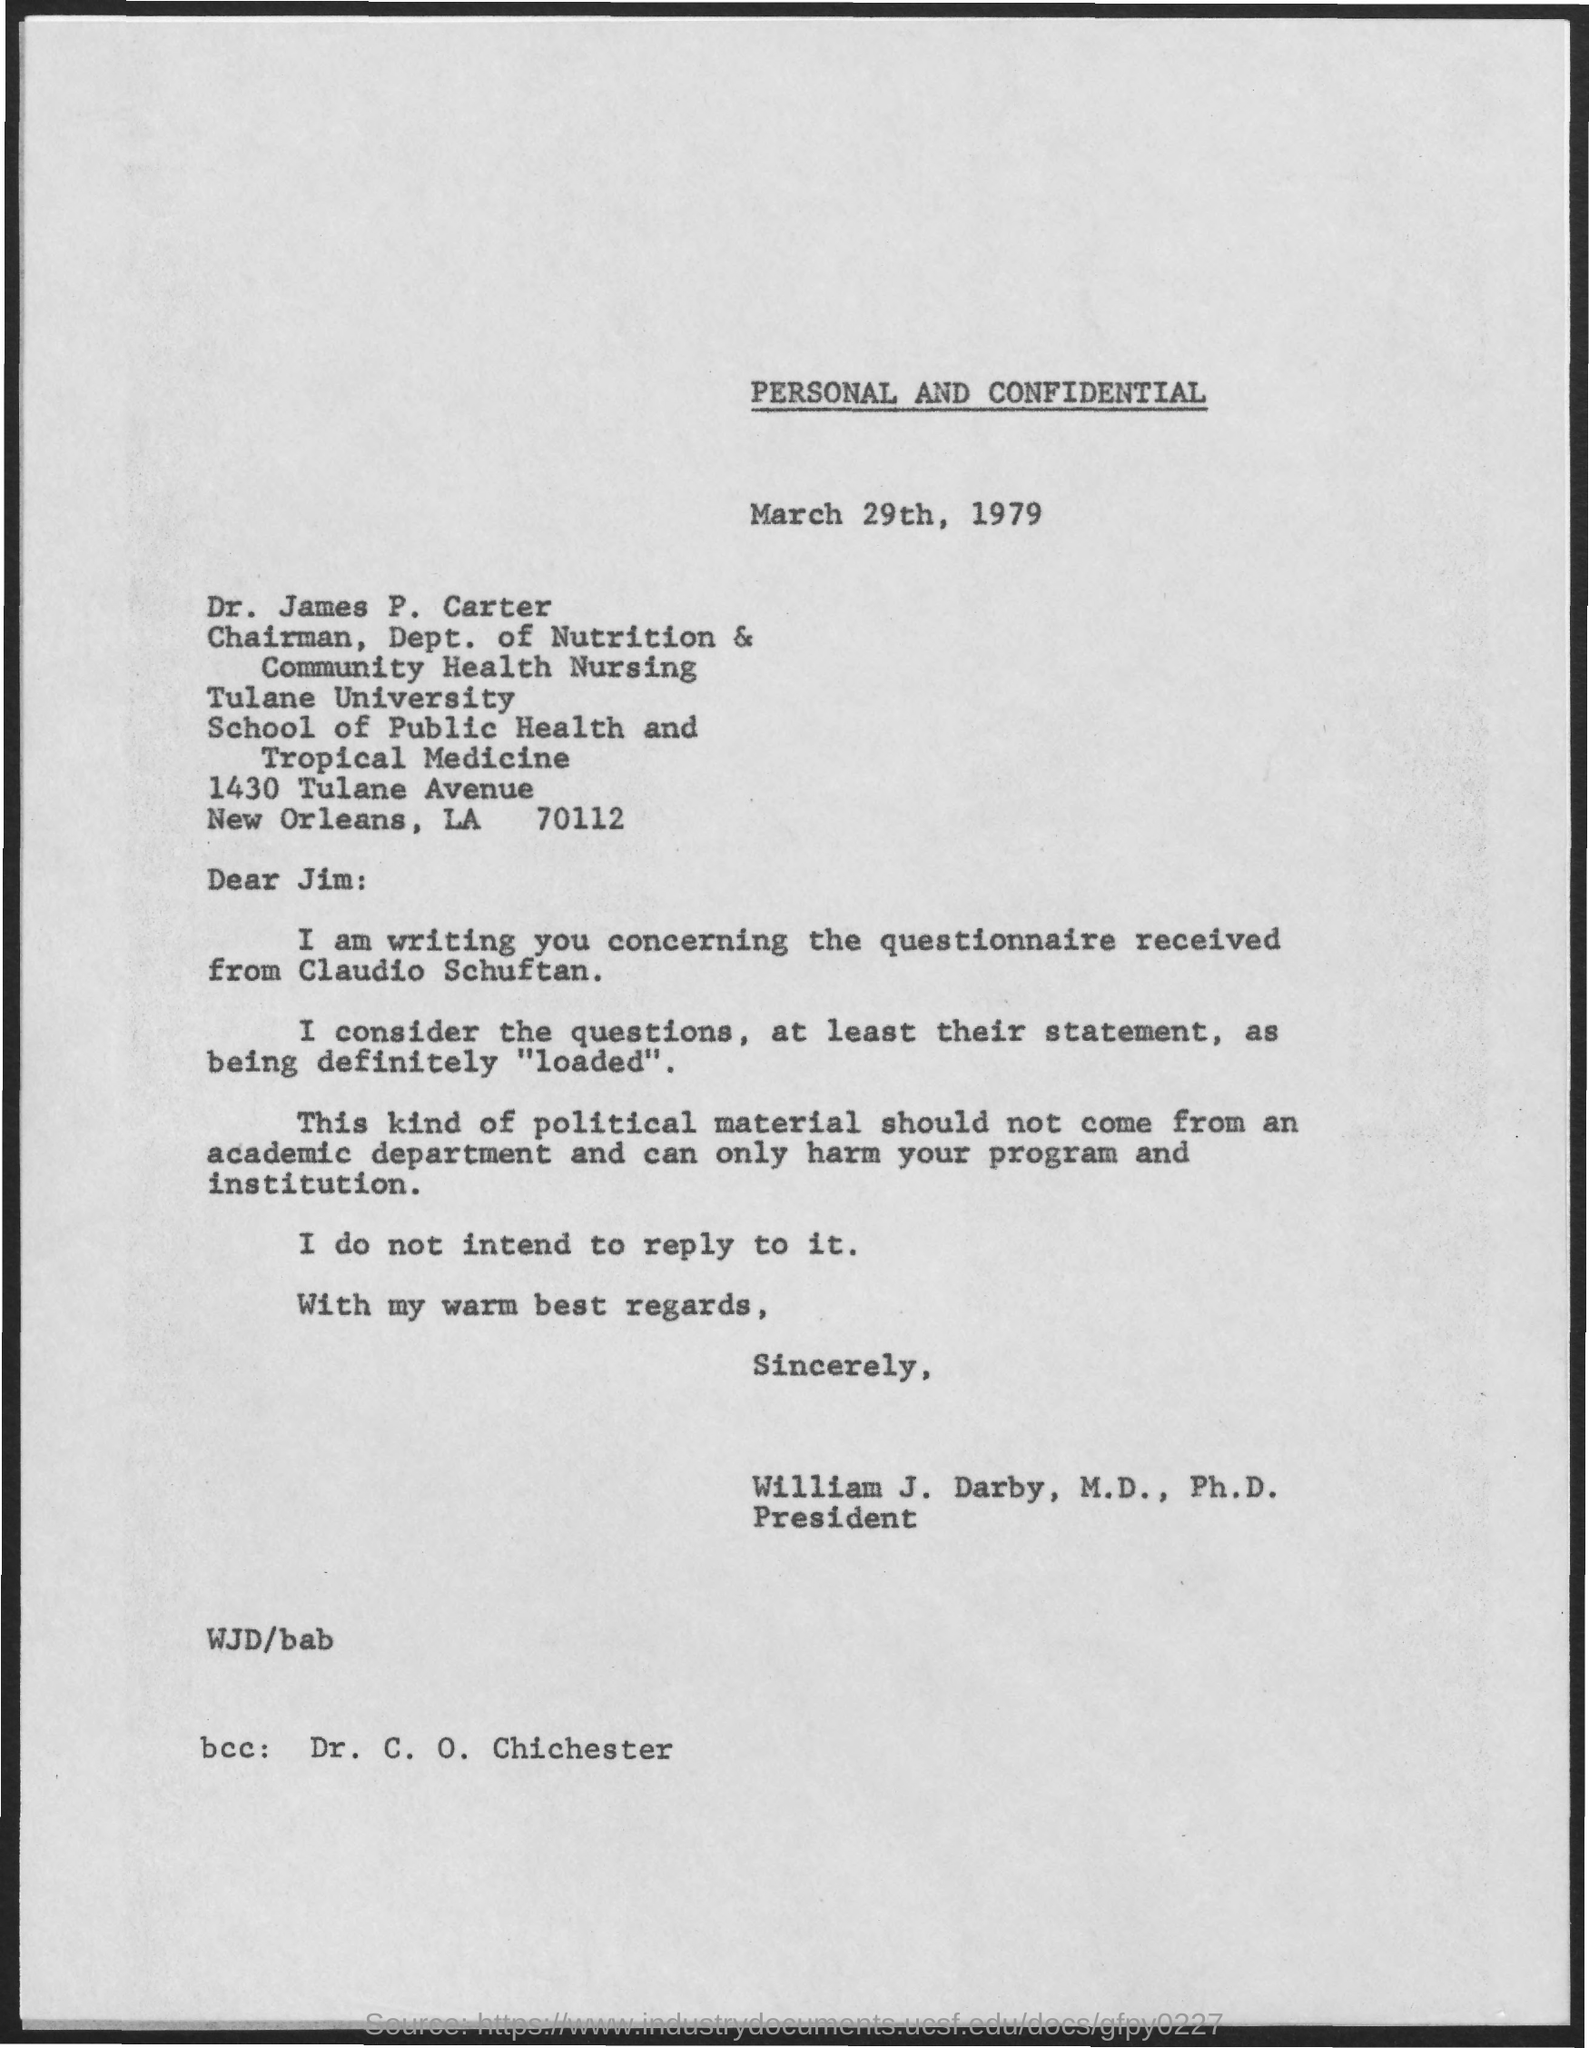What is the date mentioned ?
Offer a very short reply. March 29th , 1979. Who is the chairman of dept of nutrition & community health nursing
Provide a short and direct response. Dr. james P . Carter. What is the name of the university ?
Offer a very short reply. Tulane University. This letter is written by whom ?
Your response must be concise. William J. Darby. Who is mentioned in bcc?
Make the answer very short. Dr. C. O. Chichester. 